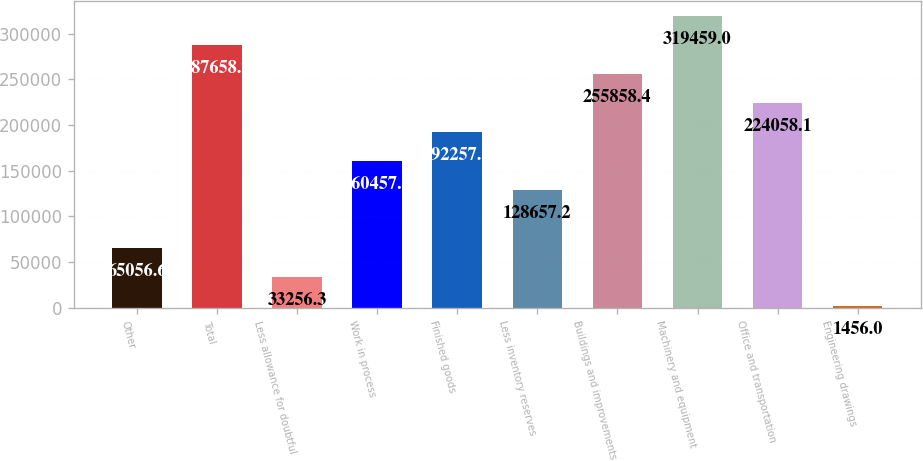<chart> <loc_0><loc_0><loc_500><loc_500><bar_chart><fcel>Other<fcel>Total<fcel>Less allowance for doubtful<fcel>Work in process<fcel>Finished goods<fcel>Less inventory reserves<fcel>Buildings and improvements<fcel>Machinery and equipment<fcel>Office and transportation<fcel>Engineering drawings<nl><fcel>65056.6<fcel>287659<fcel>33256.3<fcel>160458<fcel>192258<fcel>128657<fcel>255858<fcel>319459<fcel>224058<fcel>1456<nl></chart> 